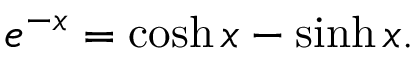<formula> <loc_0><loc_0><loc_500><loc_500>e ^ { - x } = \cosh x - \sinh x .</formula> 